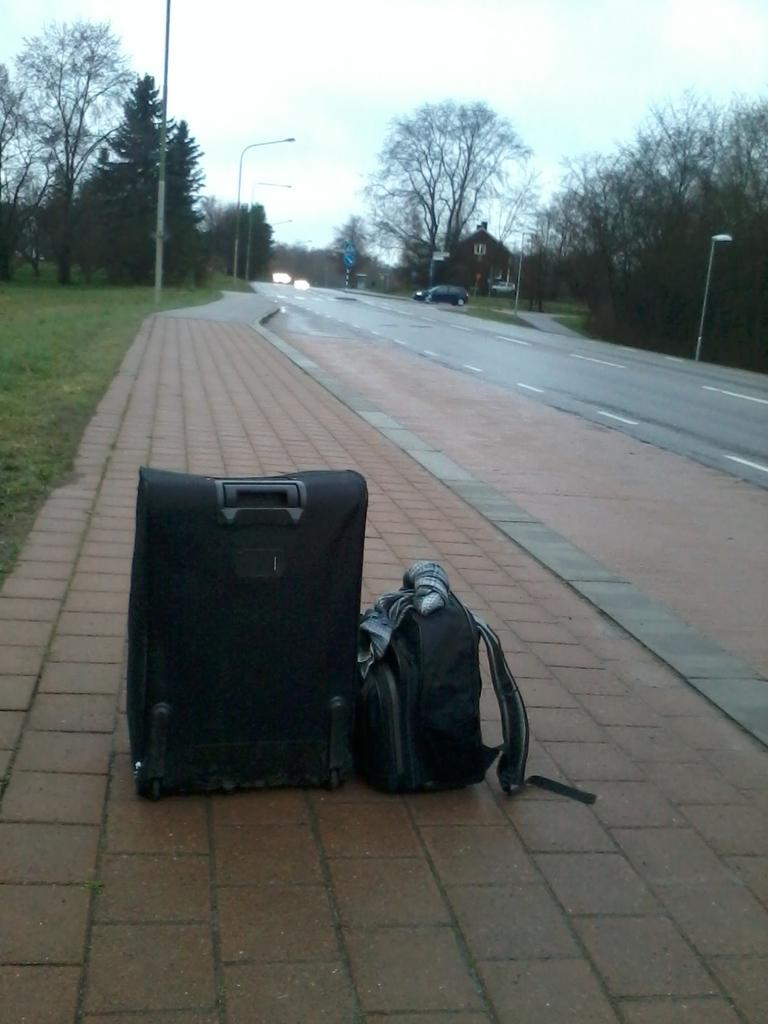How many bags can be seen on the path in the image? There are 2 bags on the path in the image. What type of vegetation is visible in the image? There is grass visible in the image. What can be seen in the background of the image? In the background of the image, there are trees, poles, and the sky. Is there any indication of a vehicle in the image? Yes, there is a car in the background of the image. What type of calendar is hanging on the tree in the image? There is no calendar present in the image; it only shows bags on the path, grass, trees, poles, the sky, and a car in the background. 